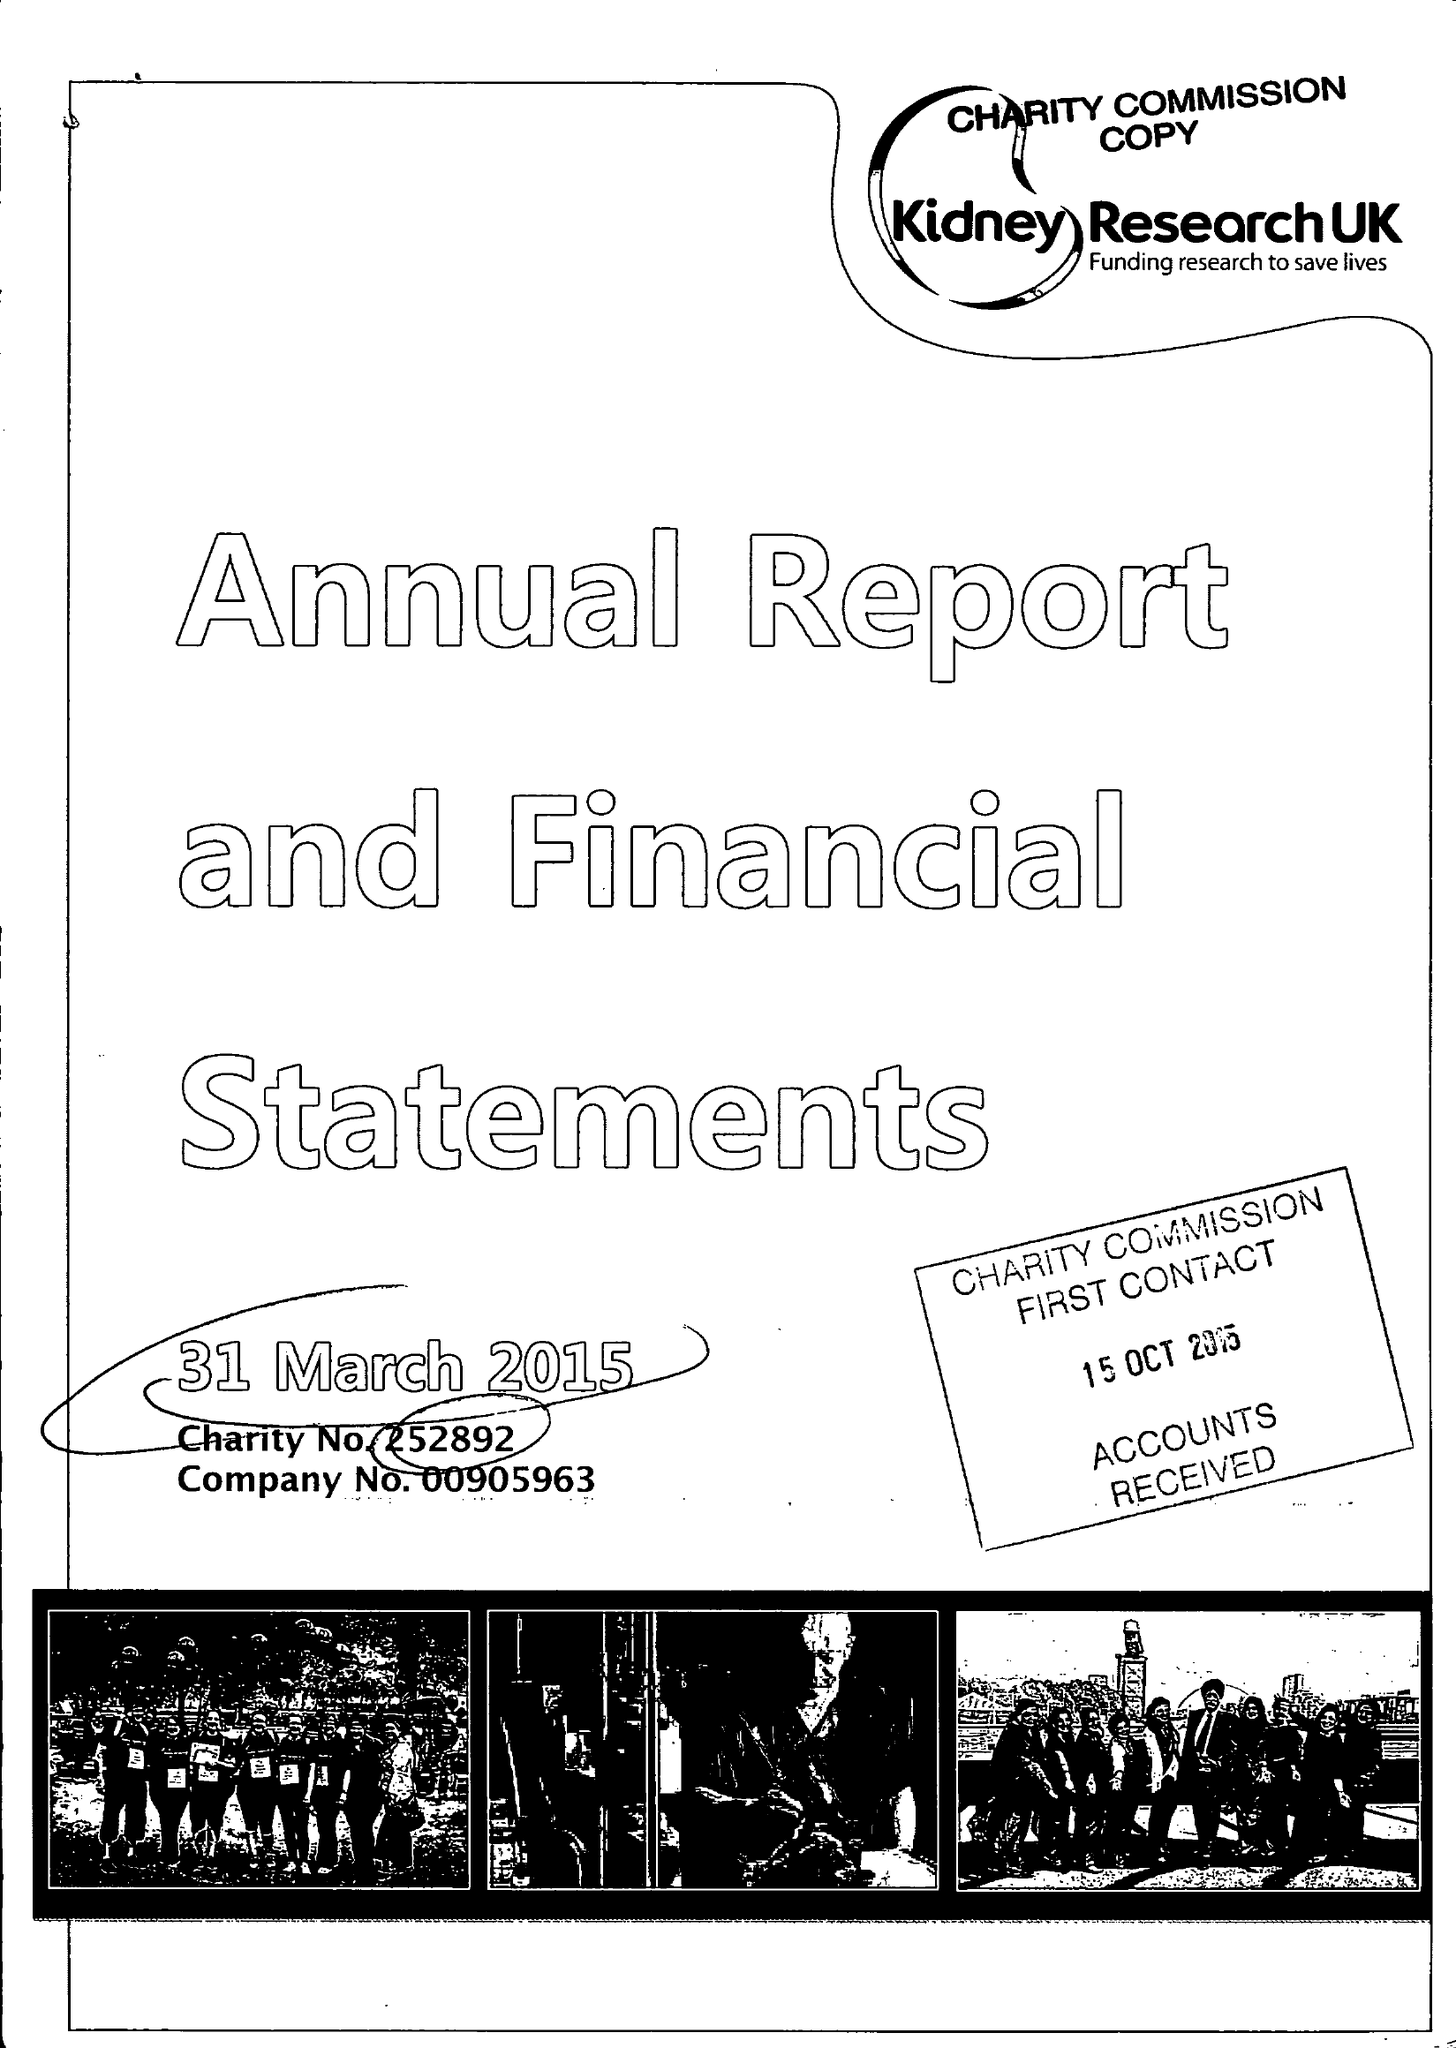What is the value for the spending_annually_in_british_pounds?
Answer the question using a single word or phrase. 9114835.00 